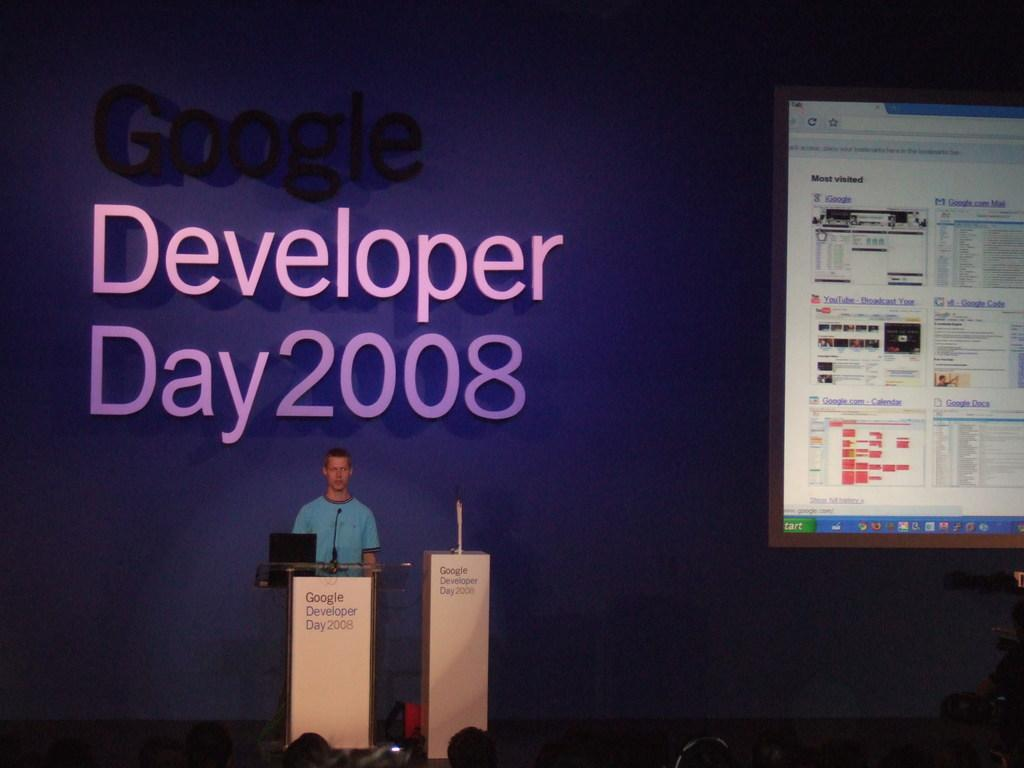<image>
Offer a succinct explanation of the picture presented. A man presenting at the Google Developer Day 2008 seminar. 